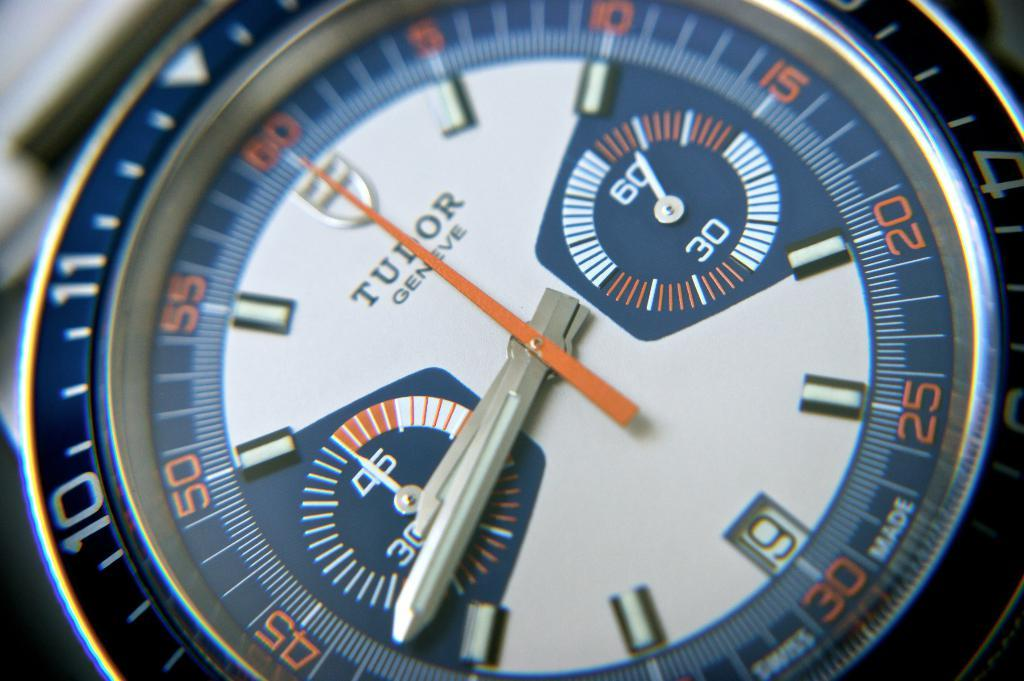<image>
Describe the image concisely. A watch has the number 9 visible on it. 